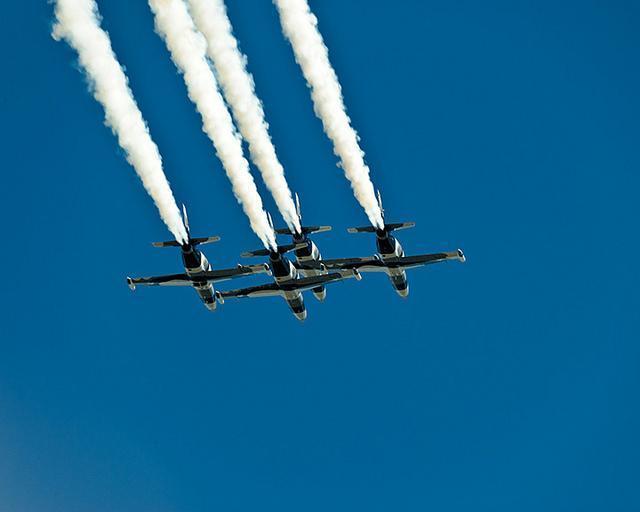How many items are in the sky?
Give a very brief answer. 4. How many planes are in the air?
Give a very brief answer. 4. How many airplanes are visible?
Give a very brief answer. 3. How many people are riding the elephant?
Give a very brief answer. 0. 